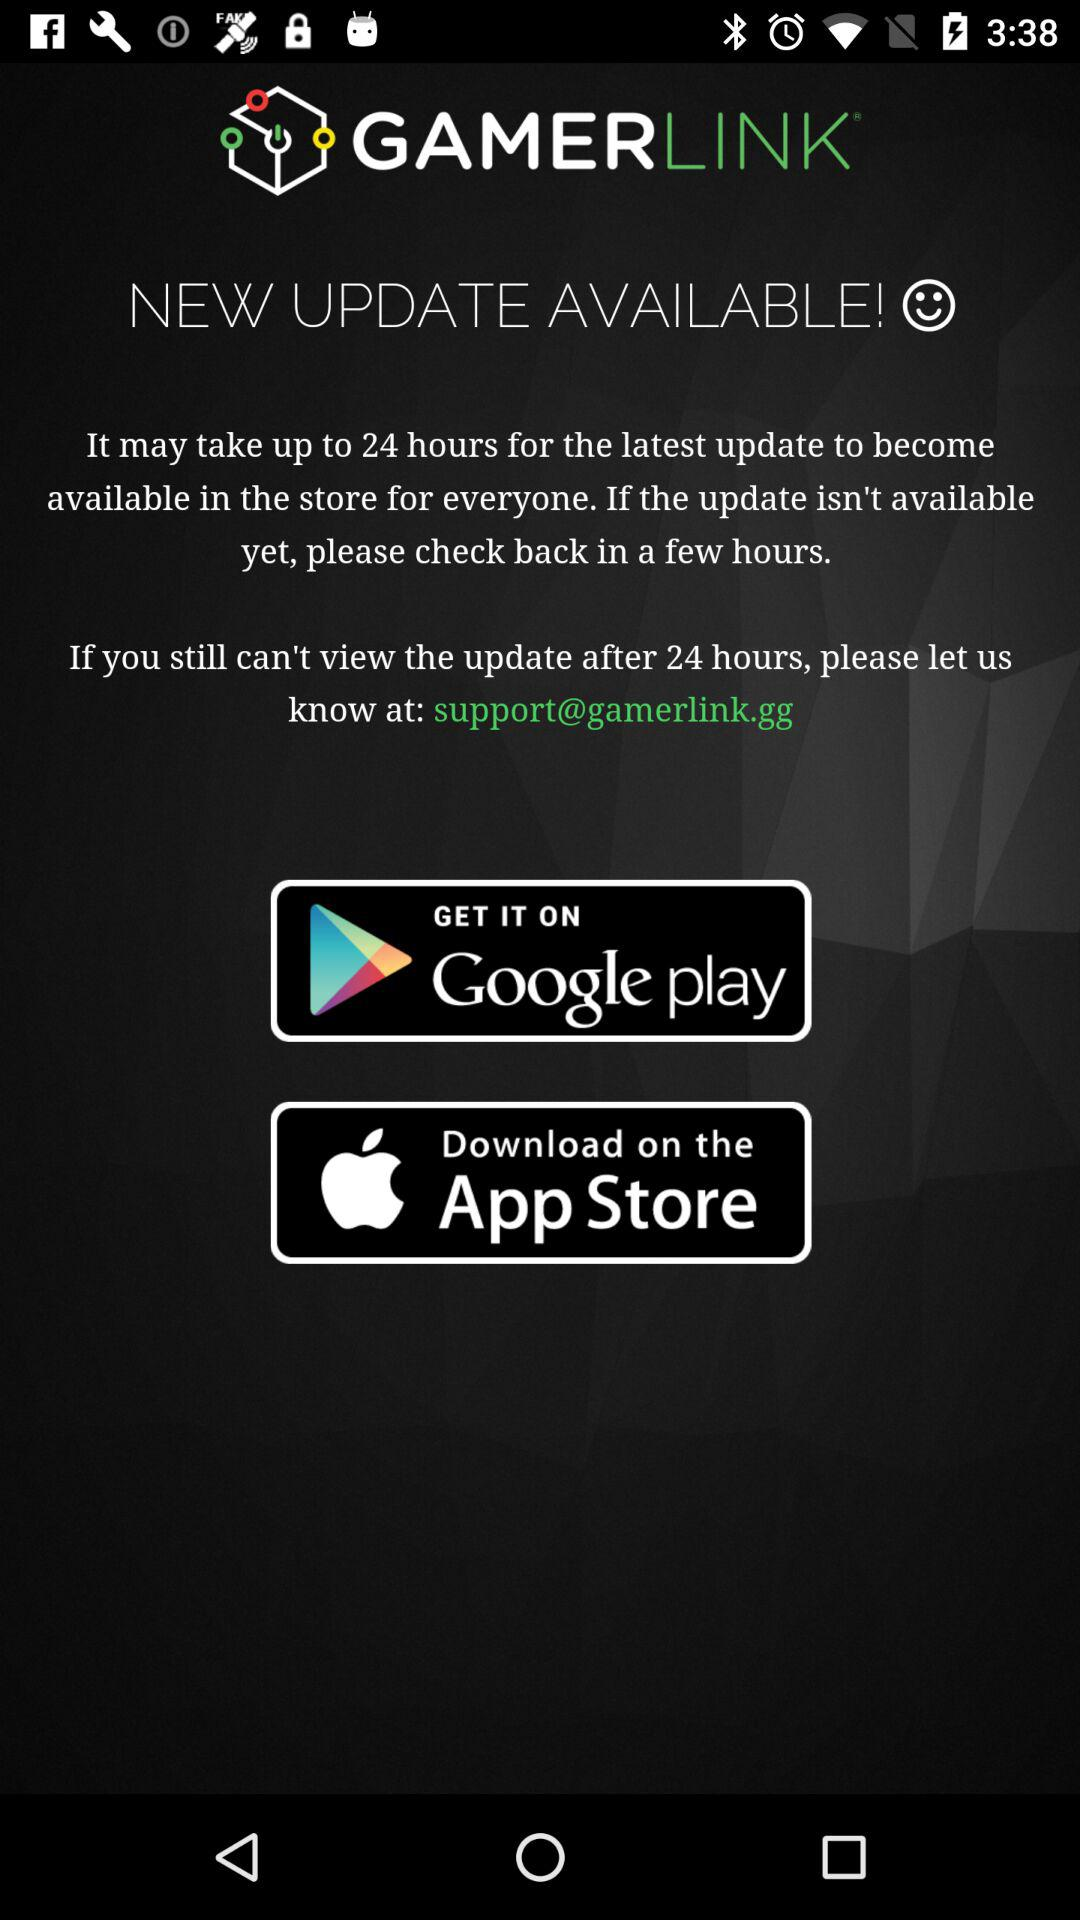How many hours will it take for the latest update? It will take up to 24 hours for the latest update. 